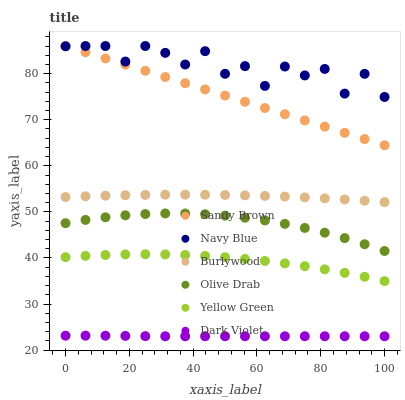Does Dark Violet have the minimum area under the curve?
Answer yes or no. Yes. Does Navy Blue have the maximum area under the curve?
Answer yes or no. Yes. Does Burlywood have the minimum area under the curve?
Answer yes or no. No. Does Burlywood have the maximum area under the curve?
Answer yes or no. No. Is Sandy Brown the smoothest?
Answer yes or no. Yes. Is Navy Blue the roughest?
Answer yes or no. Yes. Is Burlywood the smoothest?
Answer yes or no. No. Is Burlywood the roughest?
Answer yes or no. No. Does Dark Violet have the lowest value?
Answer yes or no. Yes. Does Burlywood have the lowest value?
Answer yes or no. No. Does Sandy Brown have the highest value?
Answer yes or no. Yes. Does Burlywood have the highest value?
Answer yes or no. No. Is Dark Violet less than Yellow Green?
Answer yes or no. Yes. Is Sandy Brown greater than Dark Violet?
Answer yes or no. Yes. Does Sandy Brown intersect Navy Blue?
Answer yes or no. Yes. Is Sandy Brown less than Navy Blue?
Answer yes or no. No. Is Sandy Brown greater than Navy Blue?
Answer yes or no. No. Does Dark Violet intersect Yellow Green?
Answer yes or no. No. 